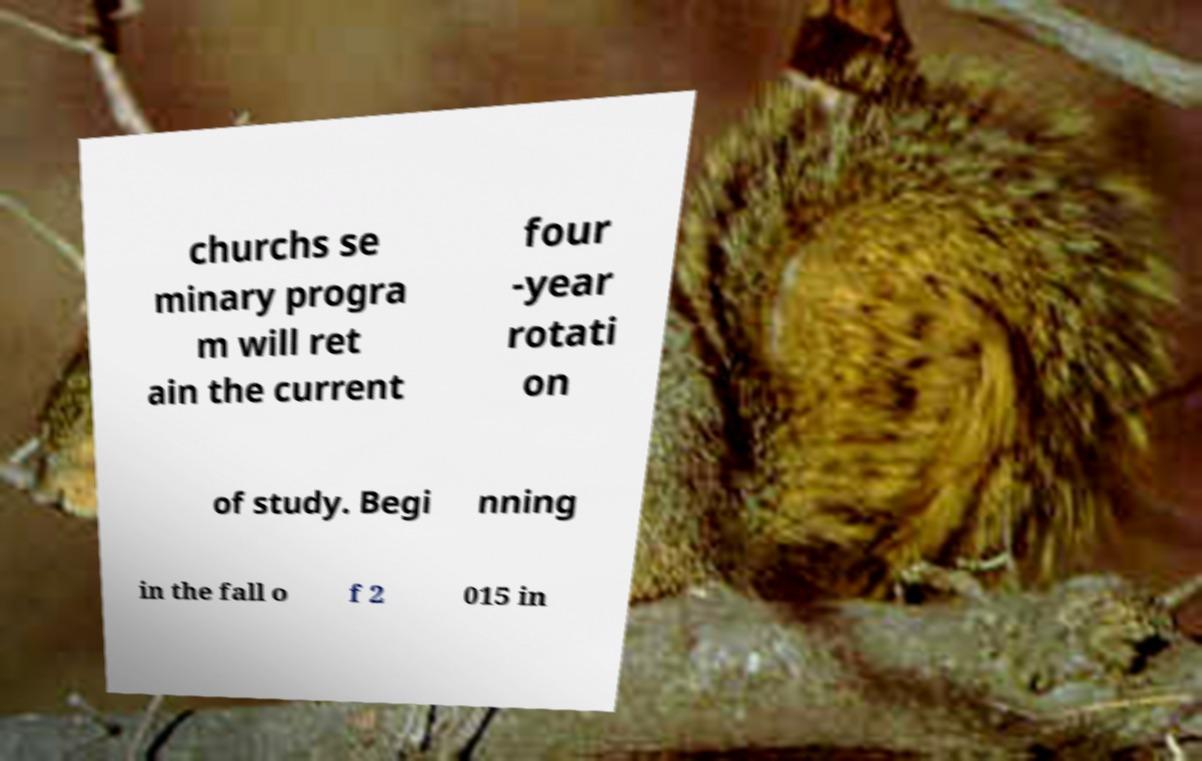There's text embedded in this image that I need extracted. Can you transcribe it verbatim? churchs se minary progra m will ret ain the current four -year rotati on of study. Begi nning in the fall o f 2 015 in 